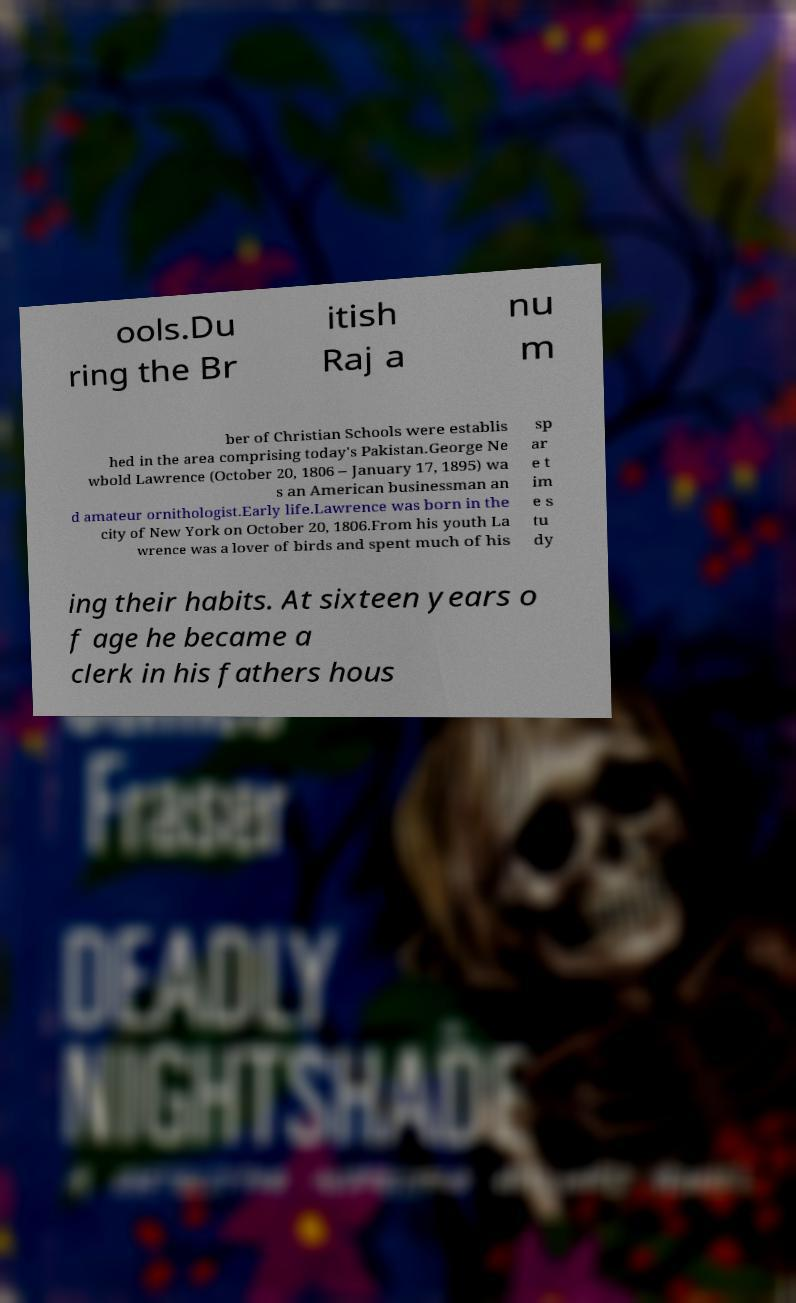Can you read and provide the text displayed in the image?This photo seems to have some interesting text. Can you extract and type it out for me? ools.Du ring the Br itish Raj a nu m ber of Christian Schools were establis hed in the area comprising today's Pakistan.George Ne wbold Lawrence (October 20, 1806 – January 17, 1895) wa s an American businessman an d amateur ornithologist.Early life.Lawrence was born in the city of New York on October 20, 1806.From his youth La wrence was a lover of birds and spent much of his sp ar e t im e s tu dy ing their habits. At sixteen years o f age he became a clerk in his fathers hous 